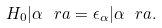Convert formula to latex. <formula><loc_0><loc_0><loc_500><loc_500>H _ { 0 } | \alpha \ r a = \epsilon _ { \alpha } | \alpha \ r a .</formula> 